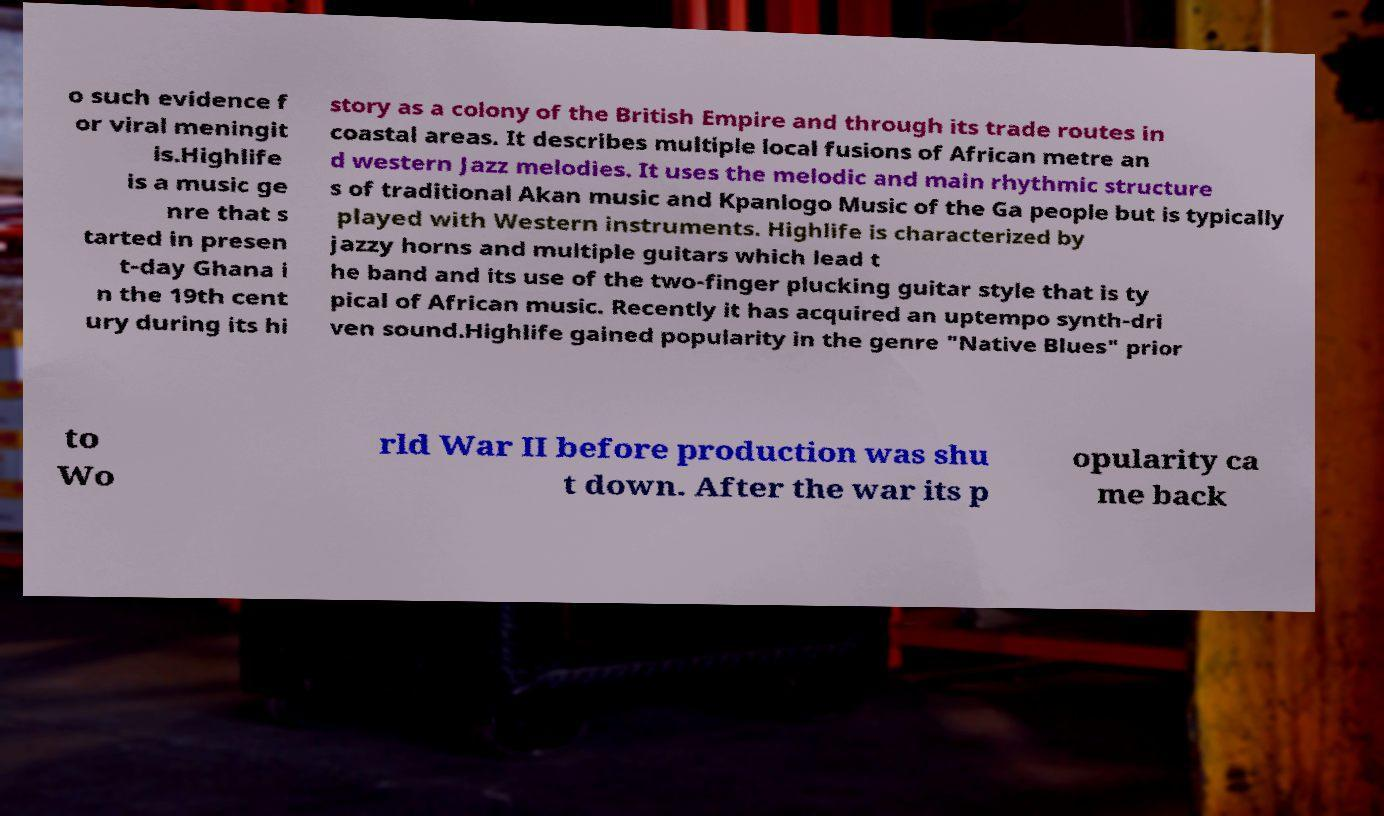For documentation purposes, I need the text within this image transcribed. Could you provide that? o such evidence f or viral meningit is.Highlife is a music ge nre that s tarted in presen t-day Ghana i n the 19th cent ury during its hi story as a colony of the British Empire and through its trade routes in coastal areas. It describes multiple local fusions of African metre an d western Jazz melodies. It uses the melodic and main rhythmic structure s of traditional Akan music and Kpanlogo Music of the Ga people but is typically played with Western instruments. Highlife is characterized by jazzy horns and multiple guitars which lead t he band and its use of the two-finger plucking guitar style that is ty pical of African music. Recently it has acquired an uptempo synth-dri ven sound.Highlife gained popularity in the genre "Native Blues" prior to Wo rld War II before production was shu t down. After the war its p opularity ca me back 